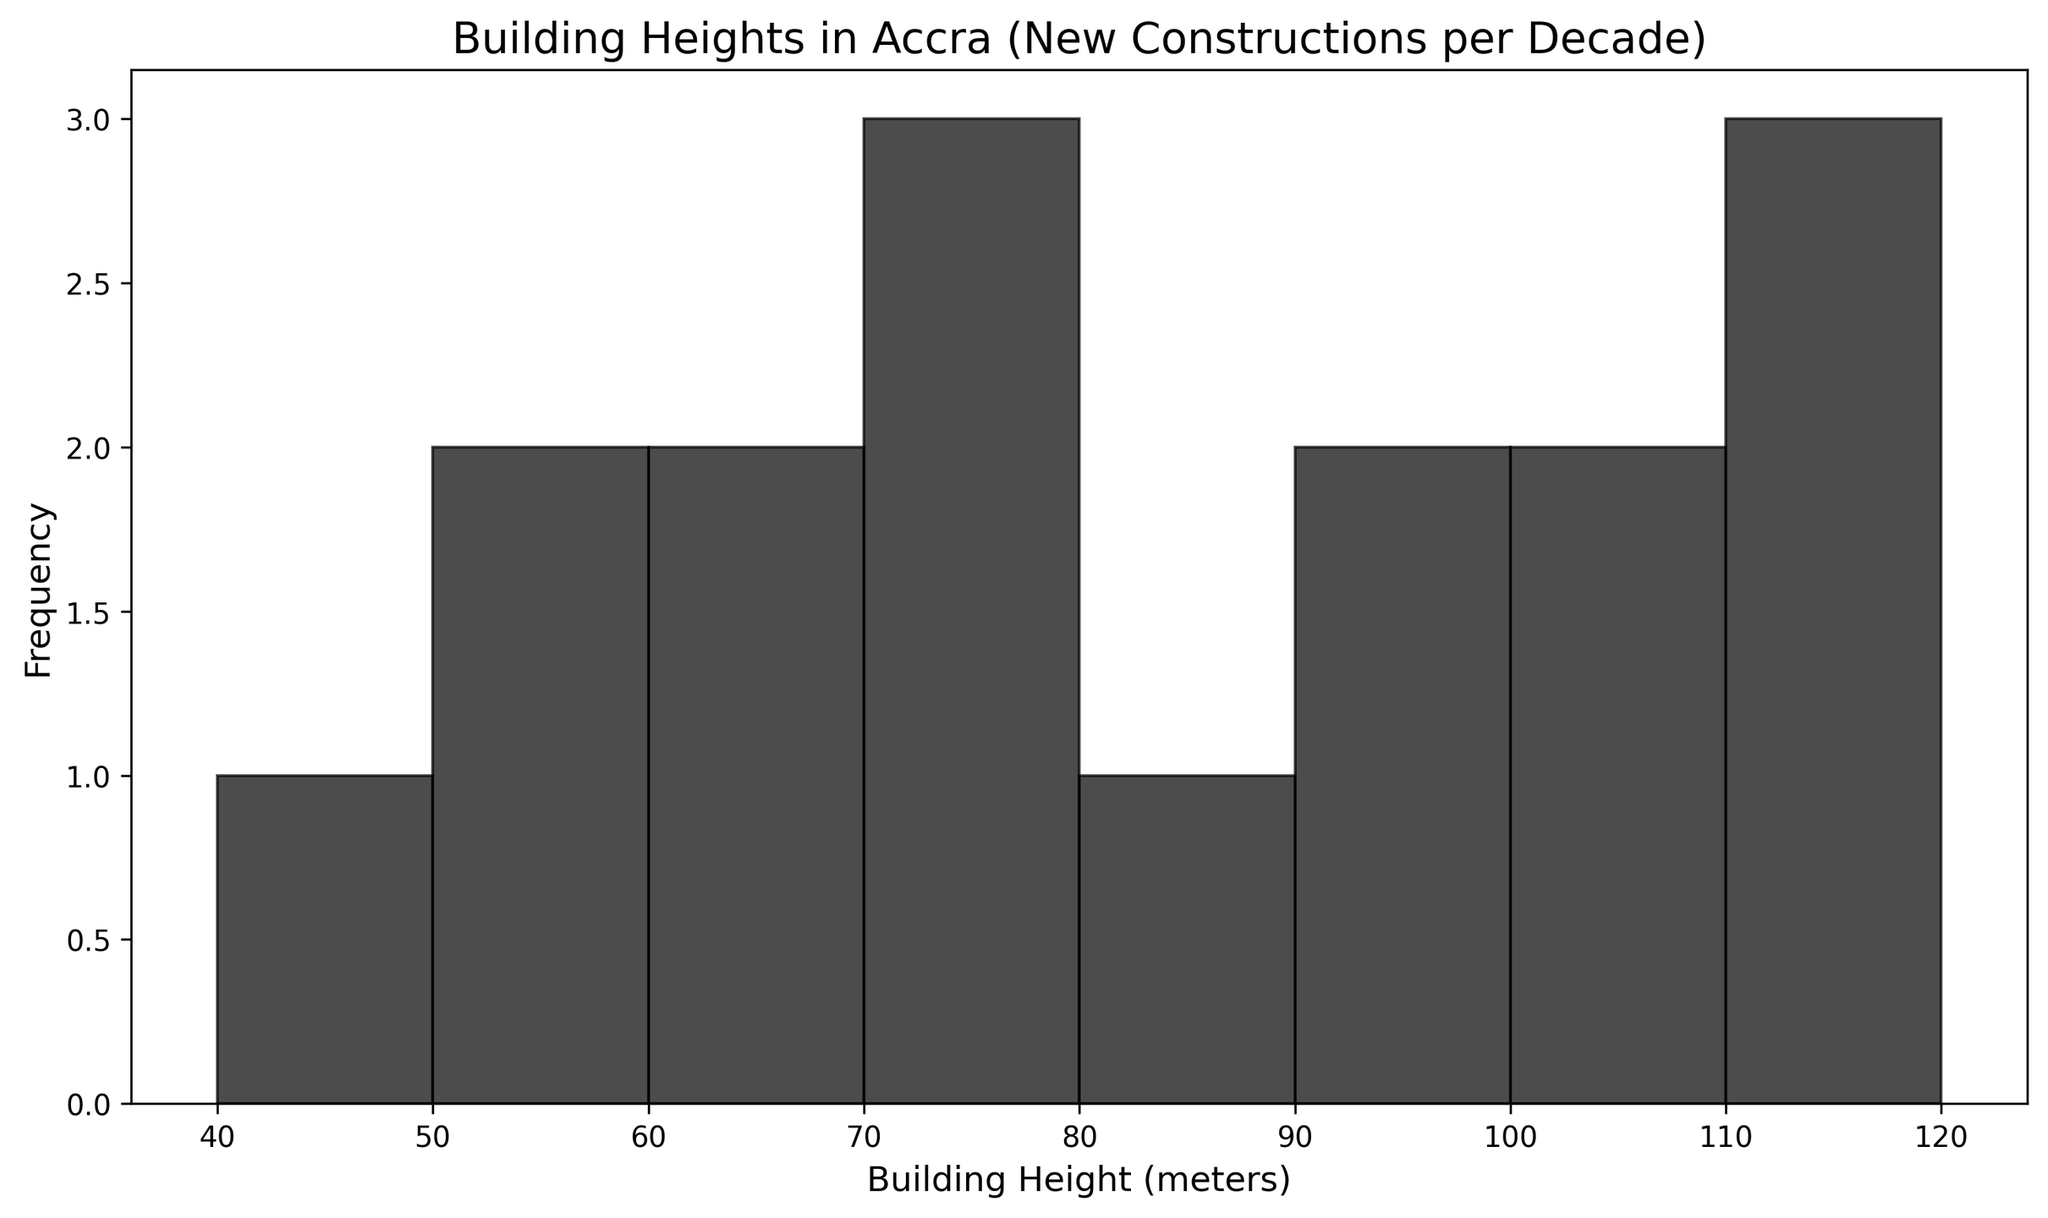What is the most common range of building heights represented on the histogram? To determine the most common range, locate the tallest bar on the histogram, which represents the frequency of building heights. The bin range with the highest bar indicates the most frequent building heights.
Answer: Between 70 and 80 meters Which decade saw the most significant increase in the number of tall buildings (e.g., buildings over 80 meters)? Examine the histogram bars corresponding to the years from each decade and identify the number of tall buildings (over 80 meters) within each decade. Compare these numbers to identify the decade with the most significant increase.
Answer: 2010s How many buildings are taller than 100 meters according to the histogram? Look at the histogram bars representing building heights over 100 meters and count the frequencies indicated by those bars. These frequencies sum up the total number of buildings taller than 100 meters.
Answer: 3 buildings What is the total number of buildings represented in the histogram? Sum the frequencies of all the histogram bars to get the total number of buildings represented in the data.
Answer: 16 buildings What is the frequency of buildings with heights between 60 and 70 meters? Identify the histogram bar representing the range between 60 and 70 meters and read off the frequency value indicated by the height of the bar.
Answer: 2 buildings Which range of building heights shows up less frequently, 50-60 meters or 90-100 meters? Compare the height of the histogram bars between the 50-60 meters range and the 90-100 meters range. The shorter bar indicates the less frequent range.
Answer: 50-60 meters What is the average height of all buildings represented in the histogram? Sum the products of the midpoints of each height range and their respective frequencies. Divide this sum by the total number of buildings to find the average height. (e.g., (47.5*1 + 57.5*1 + ... + 117.5*2) / 16).
Answer: 85 meters (approx) Which decade had the fewest new constructions? Examine the histogram bars and count the number of buildings constructed in each decade, identifying the decade with the lowest count.
Answer: 1980s How does the number of buildings in the 70-80 meter range compare to those in the 100-110 meter range? Compare the frequency values of the histogram bars representing the 70-80 meter range and the 100-110 meter range to see which has a higher frequency.
Answer: The 70-80 meter range has more buildings Do newer buildings (constructed after 2015) tend to be taller than those constructed before 2015? Compare the building heights in the histogram bars for years after 2015 to those from earlier years. Assess if the heights have generally increased.
Answer: Yes, newer buildings tend to be taller 